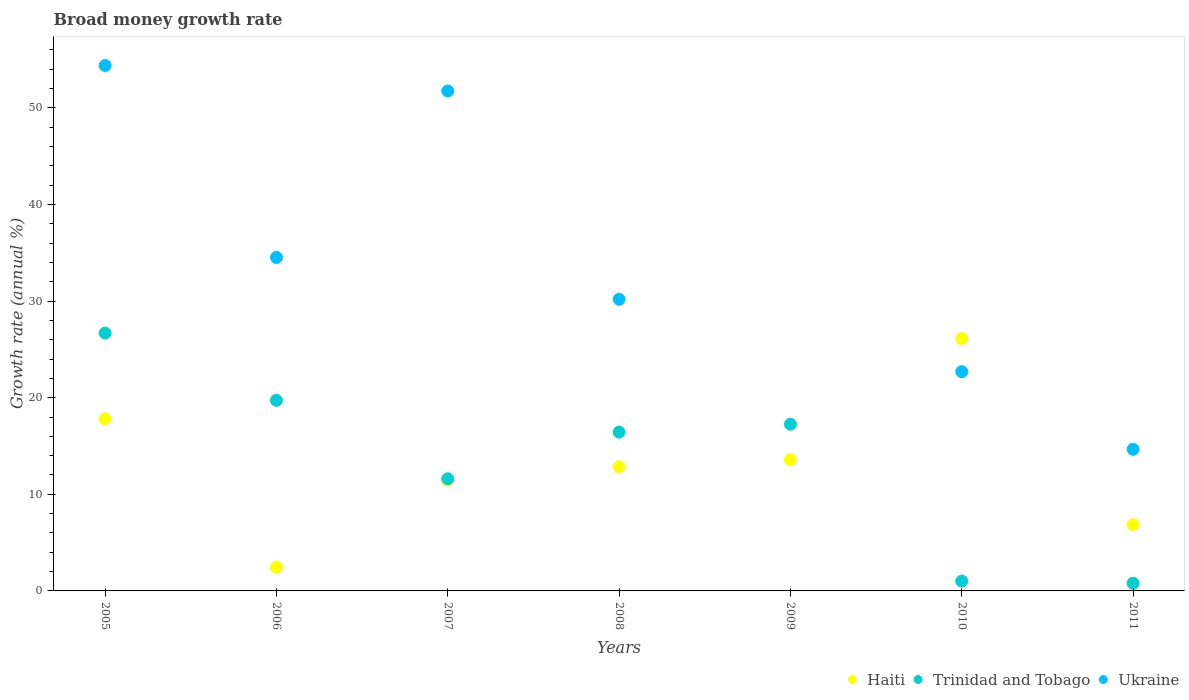How many different coloured dotlines are there?
Make the answer very short. 3. What is the growth rate in Ukraine in 2011?
Keep it short and to the point. 14.66. Across all years, what is the maximum growth rate in Trinidad and Tobago?
Give a very brief answer. 26.69. What is the total growth rate in Haiti in the graph?
Ensure brevity in your answer.  91.12. What is the difference between the growth rate in Haiti in 2009 and that in 2010?
Provide a short and direct response. -12.52. What is the difference between the growth rate in Trinidad and Tobago in 2008 and the growth rate in Haiti in 2009?
Provide a short and direct response. 2.85. What is the average growth rate in Trinidad and Tobago per year?
Your response must be concise. 13.36. In the year 2006, what is the difference between the growth rate in Trinidad and Tobago and growth rate in Haiti?
Make the answer very short. 17.29. What is the ratio of the growth rate in Ukraine in 2005 to that in 2007?
Ensure brevity in your answer.  1.05. Is the growth rate in Trinidad and Tobago in 2009 less than that in 2010?
Your answer should be very brief. No. Is the difference between the growth rate in Trinidad and Tobago in 2010 and 2011 greater than the difference between the growth rate in Haiti in 2010 and 2011?
Give a very brief answer. No. What is the difference between the highest and the second highest growth rate in Trinidad and Tobago?
Give a very brief answer. 6.96. What is the difference between the highest and the lowest growth rate in Trinidad and Tobago?
Provide a short and direct response. 25.9. In how many years, is the growth rate in Ukraine greater than the average growth rate in Ukraine taken over all years?
Provide a succinct answer. 4. Does the growth rate in Ukraine monotonically increase over the years?
Ensure brevity in your answer.  No. Is the growth rate in Ukraine strictly greater than the growth rate in Trinidad and Tobago over the years?
Ensure brevity in your answer.  No. What is the difference between two consecutive major ticks on the Y-axis?
Ensure brevity in your answer.  10. Are the values on the major ticks of Y-axis written in scientific E-notation?
Keep it short and to the point. No. Does the graph contain grids?
Make the answer very short. No. How many legend labels are there?
Ensure brevity in your answer.  3. How are the legend labels stacked?
Offer a very short reply. Horizontal. What is the title of the graph?
Ensure brevity in your answer.  Broad money growth rate. What is the label or title of the X-axis?
Keep it short and to the point. Years. What is the label or title of the Y-axis?
Your answer should be compact. Growth rate (annual %). What is the Growth rate (annual %) in Haiti in 2005?
Keep it short and to the point. 17.82. What is the Growth rate (annual %) of Trinidad and Tobago in 2005?
Offer a terse response. 26.69. What is the Growth rate (annual %) of Ukraine in 2005?
Offer a very short reply. 54.39. What is the Growth rate (annual %) of Haiti in 2006?
Your answer should be compact. 2.44. What is the Growth rate (annual %) of Trinidad and Tobago in 2006?
Your answer should be compact. 19.73. What is the Growth rate (annual %) of Ukraine in 2006?
Your answer should be compact. 34.52. What is the Growth rate (annual %) in Haiti in 2007?
Your answer should be very brief. 11.47. What is the Growth rate (annual %) of Trinidad and Tobago in 2007?
Make the answer very short. 11.61. What is the Growth rate (annual %) in Ukraine in 2007?
Ensure brevity in your answer.  51.75. What is the Growth rate (annual %) in Haiti in 2008?
Offer a terse response. 12.85. What is the Growth rate (annual %) in Trinidad and Tobago in 2008?
Offer a very short reply. 16.44. What is the Growth rate (annual %) of Ukraine in 2008?
Offer a terse response. 30.18. What is the Growth rate (annual %) in Haiti in 2009?
Your answer should be very brief. 13.59. What is the Growth rate (annual %) in Trinidad and Tobago in 2009?
Your answer should be very brief. 17.25. What is the Growth rate (annual %) in Haiti in 2010?
Offer a very short reply. 26.12. What is the Growth rate (annual %) of Trinidad and Tobago in 2010?
Keep it short and to the point. 1.02. What is the Growth rate (annual %) in Ukraine in 2010?
Provide a short and direct response. 22.69. What is the Growth rate (annual %) in Haiti in 2011?
Provide a short and direct response. 6.84. What is the Growth rate (annual %) of Trinidad and Tobago in 2011?
Your answer should be very brief. 0.79. What is the Growth rate (annual %) in Ukraine in 2011?
Your response must be concise. 14.66. Across all years, what is the maximum Growth rate (annual %) in Haiti?
Your answer should be compact. 26.12. Across all years, what is the maximum Growth rate (annual %) in Trinidad and Tobago?
Make the answer very short. 26.69. Across all years, what is the maximum Growth rate (annual %) in Ukraine?
Offer a terse response. 54.39. Across all years, what is the minimum Growth rate (annual %) of Haiti?
Your answer should be very brief. 2.44. Across all years, what is the minimum Growth rate (annual %) of Trinidad and Tobago?
Provide a succinct answer. 0.79. Across all years, what is the minimum Growth rate (annual %) in Ukraine?
Ensure brevity in your answer.  0. What is the total Growth rate (annual %) in Haiti in the graph?
Offer a terse response. 91.12. What is the total Growth rate (annual %) of Trinidad and Tobago in the graph?
Make the answer very short. 93.53. What is the total Growth rate (annual %) of Ukraine in the graph?
Offer a very short reply. 208.19. What is the difference between the Growth rate (annual %) in Haiti in 2005 and that in 2006?
Provide a succinct answer. 15.38. What is the difference between the Growth rate (annual %) of Trinidad and Tobago in 2005 and that in 2006?
Provide a succinct answer. 6.96. What is the difference between the Growth rate (annual %) of Ukraine in 2005 and that in 2006?
Make the answer very short. 19.87. What is the difference between the Growth rate (annual %) in Haiti in 2005 and that in 2007?
Your response must be concise. 6.35. What is the difference between the Growth rate (annual %) of Trinidad and Tobago in 2005 and that in 2007?
Your answer should be compact. 15.08. What is the difference between the Growth rate (annual %) of Ukraine in 2005 and that in 2007?
Ensure brevity in your answer.  2.64. What is the difference between the Growth rate (annual %) of Haiti in 2005 and that in 2008?
Offer a very short reply. 4.97. What is the difference between the Growth rate (annual %) in Trinidad and Tobago in 2005 and that in 2008?
Your answer should be compact. 10.25. What is the difference between the Growth rate (annual %) of Ukraine in 2005 and that in 2008?
Make the answer very short. 24.2. What is the difference between the Growth rate (annual %) in Haiti in 2005 and that in 2009?
Provide a succinct answer. 4.23. What is the difference between the Growth rate (annual %) in Trinidad and Tobago in 2005 and that in 2009?
Give a very brief answer. 9.44. What is the difference between the Growth rate (annual %) in Haiti in 2005 and that in 2010?
Provide a succinct answer. -8.3. What is the difference between the Growth rate (annual %) in Trinidad and Tobago in 2005 and that in 2010?
Your answer should be compact. 25.67. What is the difference between the Growth rate (annual %) in Ukraine in 2005 and that in 2010?
Your answer should be compact. 31.69. What is the difference between the Growth rate (annual %) of Haiti in 2005 and that in 2011?
Keep it short and to the point. 10.98. What is the difference between the Growth rate (annual %) in Trinidad and Tobago in 2005 and that in 2011?
Keep it short and to the point. 25.9. What is the difference between the Growth rate (annual %) in Ukraine in 2005 and that in 2011?
Make the answer very short. 39.73. What is the difference between the Growth rate (annual %) of Haiti in 2006 and that in 2007?
Provide a succinct answer. -9.02. What is the difference between the Growth rate (annual %) of Trinidad and Tobago in 2006 and that in 2007?
Your answer should be very brief. 8.13. What is the difference between the Growth rate (annual %) in Ukraine in 2006 and that in 2007?
Provide a short and direct response. -17.23. What is the difference between the Growth rate (annual %) of Haiti in 2006 and that in 2008?
Make the answer very short. -10.4. What is the difference between the Growth rate (annual %) of Trinidad and Tobago in 2006 and that in 2008?
Ensure brevity in your answer.  3.3. What is the difference between the Growth rate (annual %) of Ukraine in 2006 and that in 2008?
Make the answer very short. 4.34. What is the difference between the Growth rate (annual %) of Haiti in 2006 and that in 2009?
Offer a terse response. -11.15. What is the difference between the Growth rate (annual %) in Trinidad and Tobago in 2006 and that in 2009?
Offer a terse response. 2.48. What is the difference between the Growth rate (annual %) of Haiti in 2006 and that in 2010?
Keep it short and to the point. -23.67. What is the difference between the Growth rate (annual %) of Trinidad and Tobago in 2006 and that in 2010?
Ensure brevity in your answer.  18.72. What is the difference between the Growth rate (annual %) in Ukraine in 2006 and that in 2010?
Your answer should be compact. 11.83. What is the difference between the Growth rate (annual %) of Haiti in 2006 and that in 2011?
Give a very brief answer. -4.4. What is the difference between the Growth rate (annual %) in Trinidad and Tobago in 2006 and that in 2011?
Provide a short and direct response. 18.94. What is the difference between the Growth rate (annual %) in Ukraine in 2006 and that in 2011?
Make the answer very short. 19.86. What is the difference between the Growth rate (annual %) in Haiti in 2007 and that in 2008?
Provide a short and direct response. -1.38. What is the difference between the Growth rate (annual %) in Trinidad and Tobago in 2007 and that in 2008?
Keep it short and to the point. -4.83. What is the difference between the Growth rate (annual %) in Ukraine in 2007 and that in 2008?
Provide a short and direct response. 21.56. What is the difference between the Growth rate (annual %) in Haiti in 2007 and that in 2009?
Ensure brevity in your answer.  -2.12. What is the difference between the Growth rate (annual %) in Trinidad and Tobago in 2007 and that in 2009?
Provide a short and direct response. -5.65. What is the difference between the Growth rate (annual %) in Haiti in 2007 and that in 2010?
Provide a short and direct response. -14.65. What is the difference between the Growth rate (annual %) in Trinidad and Tobago in 2007 and that in 2010?
Give a very brief answer. 10.59. What is the difference between the Growth rate (annual %) in Ukraine in 2007 and that in 2010?
Offer a terse response. 29.06. What is the difference between the Growth rate (annual %) in Haiti in 2007 and that in 2011?
Your response must be concise. 4.62. What is the difference between the Growth rate (annual %) of Trinidad and Tobago in 2007 and that in 2011?
Provide a short and direct response. 10.82. What is the difference between the Growth rate (annual %) of Ukraine in 2007 and that in 2011?
Offer a very short reply. 37.09. What is the difference between the Growth rate (annual %) in Haiti in 2008 and that in 2009?
Your response must be concise. -0.75. What is the difference between the Growth rate (annual %) in Trinidad and Tobago in 2008 and that in 2009?
Your answer should be compact. -0.82. What is the difference between the Growth rate (annual %) of Haiti in 2008 and that in 2010?
Keep it short and to the point. -13.27. What is the difference between the Growth rate (annual %) in Trinidad and Tobago in 2008 and that in 2010?
Provide a short and direct response. 15.42. What is the difference between the Growth rate (annual %) of Ukraine in 2008 and that in 2010?
Offer a terse response. 7.49. What is the difference between the Growth rate (annual %) in Haiti in 2008 and that in 2011?
Provide a succinct answer. 6. What is the difference between the Growth rate (annual %) in Trinidad and Tobago in 2008 and that in 2011?
Give a very brief answer. 15.65. What is the difference between the Growth rate (annual %) of Ukraine in 2008 and that in 2011?
Ensure brevity in your answer.  15.52. What is the difference between the Growth rate (annual %) of Haiti in 2009 and that in 2010?
Make the answer very short. -12.52. What is the difference between the Growth rate (annual %) of Trinidad and Tobago in 2009 and that in 2010?
Provide a short and direct response. 16.24. What is the difference between the Growth rate (annual %) in Haiti in 2009 and that in 2011?
Your response must be concise. 6.75. What is the difference between the Growth rate (annual %) of Trinidad and Tobago in 2009 and that in 2011?
Keep it short and to the point. 16.46. What is the difference between the Growth rate (annual %) of Haiti in 2010 and that in 2011?
Offer a terse response. 19.27. What is the difference between the Growth rate (annual %) of Trinidad and Tobago in 2010 and that in 2011?
Provide a short and direct response. 0.23. What is the difference between the Growth rate (annual %) of Ukraine in 2010 and that in 2011?
Your answer should be very brief. 8.03. What is the difference between the Growth rate (annual %) of Haiti in 2005 and the Growth rate (annual %) of Trinidad and Tobago in 2006?
Provide a succinct answer. -1.92. What is the difference between the Growth rate (annual %) of Haiti in 2005 and the Growth rate (annual %) of Ukraine in 2006?
Offer a very short reply. -16.7. What is the difference between the Growth rate (annual %) in Trinidad and Tobago in 2005 and the Growth rate (annual %) in Ukraine in 2006?
Keep it short and to the point. -7.83. What is the difference between the Growth rate (annual %) of Haiti in 2005 and the Growth rate (annual %) of Trinidad and Tobago in 2007?
Make the answer very short. 6.21. What is the difference between the Growth rate (annual %) of Haiti in 2005 and the Growth rate (annual %) of Ukraine in 2007?
Give a very brief answer. -33.93. What is the difference between the Growth rate (annual %) in Trinidad and Tobago in 2005 and the Growth rate (annual %) in Ukraine in 2007?
Provide a succinct answer. -25.06. What is the difference between the Growth rate (annual %) of Haiti in 2005 and the Growth rate (annual %) of Trinidad and Tobago in 2008?
Your answer should be compact. 1.38. What is the difference between the Growth rate (annual %) of Haiti in 2005 and the Growth rate (annual %) of Ukraine in 2008?
Provide a short and direct response. -12.36. What is the difference between the Growth rate (annual %) of Trinidad and Tobago in 2005 and the Growth rate (annual %) of Ukraine in 2008?
Provide a short and direct response. -3.49. What is the difference between the Growth rate (annual %) of Haiti in 2005 and the Growth rate (annual %) of Trinidad and Tobago in 2009?
Ensure brevity in your answer.  0.57. What is the difference between the Growth rate (annual %) in Haiti in 2005 and the Growth rate (annual %) in Trinidad and Tobago in 2010?
Provide a short and direct response. 16.8. What is the difference between the Growth rate (annual %) in Haiti in 2005 and the Growth rate (annual %) in Ukraine in 2010?
Keep it short and to the point. -4.87. What is the difference between the Growth rate (annual %) in Trinidad and Tobago in 2005 and the Growth rate (annual %) in Ukraine in 2010?
Keep it short and to the point. 4. What is the difference between the Growth rate (annual %) in Haiti in 2005 and the Growth rate (annual %) in Trinidad and Tobago in 2011?
Provide a short and direct response. 17.03. What is the difference between the Growth rate (annual %) of Haiti in 2005 and the Growth rate (annual %) of Ukraine in 2011?
Ensure brevity in your answer.  3.16. What is the difference between the Growth rate (annual %) in Trinidad and Tobago in 2005 and the Growth rate (annual %) in Ukraine in 2011?
Your answer should be compact. 12.03. What is the difference between the Growth rate (annual %) in Haiti in 2006 and the Growth rate (annual %) in Trinidad and Tobago in 2007?
Your response must be concise. -9.16. What is the difference between the Growth rate (annual %) of Haiti in 2006 and the Growth rate (annual %) of Ukraine in 2007?
Give a very brief answer. -49.3. What is the difference between the Growth rate (annual %) in Trinidad and Tobago in 2006 and the Growth rate (annual %) in Ukraine in 2007?
Your answer should be compact. -32.01. What is the difference between the Growth rate (annual %) of Haiti in 2006 and the Growth rate (annual %) of Trinidad and Tobago in 2008?
Offer a very short reply. -13.99. What is the difference between the Growth rate (annual %) of Haiti in 2006 and the Growth rate (annual %) of Ukraine in 2008?
Provide a short and direct response. -27.74. What is the difference between the Growth rate (annual %) in Trinidad and Tobago in 2006 and the Growth rate (annual %) in Ukraine in 2008?
Provide a short and direct response. -10.45. What is the difference between the Growth rate (annual %) of Haiti in 2006 and the Growth rate (annual %) of Trinidad and Tobago in 2009?
Offer a terse response. -14.81. What is the difference between the Growth rate (annual %) of Haiti in 2006 and the Growth rate (annual %) of Trinidad and Tobago in 2010?
Ensure brevity in your answer.  1.43. What is the difference between the Growth rate (annual %) of Haiti in 2006 and the Growth rate (annual %) of Ukraine in 2010?
Offer a terse response. -20.25. What is the difference between the Growth rate (annual %) in Trinidad and Tobago in 2006 and the Growth rate (annual %) in Ukraine in 2010?
Ensure brevity in your answer.  -2.96. What is the difference between the Growth rate (annual %) in Haiti in 2006 and the Growth rate (annual %) in Trinidad and Tobago in 2011?
Provide a short and direct response. 1.65. What is the difference between the Growth rate (annual %) in Haiti in 2006 and the Growth rate (annual %) in Ukraine in 2011?
Provide a short and direct response. -12.22. What is the difference between the Growth rate (annual %) of Trinidad and Tobago in 2006 and the Growth rate (annual %) of Ukraine in 2011?
Make the answer very short. 5.08. What is the difference between the Growth rate (annual %) in Haiti in 2007 and the Growth rate (annual %) in Trinidad and Tobago in 2008?
Offer a very short reply. -4.97. What is the difference between the Growth rate (annual %) of Haiti in 2007 and the Growth rate (annual %) of Ukraine in 2008?
Provide a succinct answer. -18.72. What is the difference between the Growth rate (annual %) in Trinidad and Tobago in 2007 and the Growth rate (annual %) in Ukraine in 2008?
Your answer should be compact. -18.58. What is the difference between the Growth rate (annual %) of Haiti in 2007 and the Growth rate (annual %) of Trinidad and Tobago in 2009?
Your answer should be very brief. -5.79. What is the difference between the Growth rate (annual %) of Haiti in 2007 and the Growth rate (annual %) of Trinidad and Tobago in 2010?
Ensure brevity in your answer.  10.45. What is the difference between the Growth rate (annual %) of Haiti in 2007 and the Growth rate (annual %) of Ukraine in 2010?
Your response must be concise. -11.22. What is the difference between the Growth rate (annual %) in Trinidad and Tobago in 2007 and the Growth rate (annual %) in Ukraine in 2010?
Ensure brevity in your answer.  -11.08. What is the difference between the Growth rate (annual %) of Haiti in 2007 and the Growth rate (annual %) of Trinidad and Tobago in 2011?
Give a very brief answer. 10.68. What is the difference between the Growth rate (annual %) in Haiti in 2007 and the Growth rate (annual %) in Ukraine in 2011?
Make the answer very short. -3.19. What is the difference between the Growth rate (annual %) in Trinidad and Tobago in 2007 and the Growth rate (annual %) in Ukraine in 2011?
Offer a very short reply. -3.05. What is the difference between the Growth rate (annual %) in Haiti in 2008 and the Growth rate (annual %) in Trinidad and Tobago in 2009?
Provide a succinct answer. -4.41. What is the difference between the Growth rate (annual %) in Haiti in 2008 and the Growth rate (annual %) in Trinidad and Tobago in 2010?
Give a very brief answer. 11.83. What is the difference between the Growth rate (annual %) in Haiti in 2008 and the Growth rate (annual %) in Ukraine in 2010?
Your answer should be compact. -9.85. What is the difference between the Growth rate (annual %) of Trinidad and Tobago in 2008 and the Growth rate (annual %) of Ukraine in 2010?
Offer a very short reply. -6.25. What is the difference between the Growth rate (annual %) of Haiti in 2008 and the Growth rate (annual %) of Trinidad and Tobago in 2011?
Keep it short and to the point. 12.06. What is the difference between the Growth rate (annual %) of Haiti in 2008 and the Growth rate (annual %) of Ukraine in 2011?
Your answer should be compact. -1.81. What is the difference between the Growth rate (annual %) of Trinidad and Tobago in 2008 and the Growth rate (annual %) of Ukraine in 2011?
Ensure brevity in your answer.  1.78. What is the difference between the Growth rate (annual %) of Haiti in 2009 and the Growth rate (annual %) of Trinidad and Tobago in 2010?
Your answer should be very brief. 12.57. What is the difference between the Growth rate (annual %) of Haiti in 2009 and the Growth rate (annual %) of Ukraine in 2010?
Provide a short and direct response. -9.1. What is the difference between the Growth rate (annual %) in Trinidad and Tobago in 2009 and the Growth rate (annual %) in Ukraine in 2010?
Offer a terse response. -5.44. What is the difference between the Growth rate (annual %) in Haiti in 2009 and the Growth rate (annual %) in Trinidad and Tobago in 2011?
Provide a succinct answer. 12.8. What is the difference between the Growth rate (annual %) of Haiti in 2009 and the Growth rate (annual %) of Ukraine in 2011?
Your response must be concise. -1.07. What is the difference between the Growth rate (annual %) in Trinidad and Tobago in 2009 and the Growth rate (annual %) in Ukraine in 2011?
Provide a short and direct response. 2.59. What is the difference between the Growth rate (annual %) of Haiti in 2010 and the Growth rate (annual %) of Trinidad and Tobago in 2011?
Your answer should be compact. 25.33. What is the difference between the Growth rate (annual %) in Haiti in 2010 and the Growth rate (annual %) in Ukraine in 2011?
Your response must be concise. 11.46. What is the difference between the Growth rate (annual %) in Trinidad and Tobago in 2010 and the Growth rate (annual %) in Ukraine in 2011?
Keep it short and to the point. -13.64. What is the average Growth rate (annual %) in Haiti per year?
Give a very brief answer. 13.02. What is the average Growth rate (annual %) in Trinidad and Tobago per year?
Your answer should be compact. 13.36. What is the average Growth rate (annual %) of Ukraine per year?
Your response must be concise. 29.74. In the year 2005, what is the difference between the Growth rate (annual %) in Haiti and Growth rate (annual %) in Trinidad and Tobago?
Make the answer very short. -8.87. In the year 2005, what is the difference between the Growth rate (annual %) in Haiti and Growth rate (annual %) in Ukraine?
Keep it short and to the point. -36.57. In the year 2005, what is the difference between the Growth rate (annual %) in Trinidad and Tobago and Growth rate (annual %) in Ukraine?
Ensure brevity in your answer.  -27.69. In the year 2006, what is the difference between the Growth rate (annual %) in Haiti and Growth rate (annual %) in Trinidad and Tobago?
Make the answer very short. -17.29. In the year 2006, what is the difference between the Growth rate (annual %) of Haiti and Growth rate (annual %) of Ukraine?
Provide a succinct answer. -32.08. In the year 2006, what is the difference between the Growth rate (annual %) of Trinidad and Tobago and Growth rate (annual %) of Ukraine?
Provide a succinct answer. -14.79. In the year 2007, what is the difference between the Growth rate (annual %) of Haiti and Growth rate (annual %) of Trinidad and Tobago?
Offer a very short reply. -0.14. In the year 2007, what is the difference between the Growth rate (annual %) in Haiti and Growth rate (annual %) in Ukraine?
Provide a short and direct response. -40.28. In the year 2007, what is the difference between the Growth rate (annual %) in Trinidad and Tobago and Growth rate (annual %) in Ukraine?
Give a very brief answer. -40.14. In the year 2008, what is the difference between the Growth rate (annual %) of Haiti and Growth rate (annual %) of Trinidad and Tobago?
Make the answer very short. -3.59. In the year 2008, what is the difference between the Growth rate (annual %) of Haiti and Growth rate (annual %) of Ukraine?
Offer a very short reply. -17.34. In the year 2008, what is the difference between the Growth rate (annual %) in Trinidad and Tobago and Growth rate (annual %) in Ukraine?
Your answer should be compact. -13.74. In the year 2009, what is the difference between the Growth rate (annual %) in Haiti and Growth rate (annual %) in Trinidad and Tobago?
Your answer should be very brief. -3.66. In the year 2010, what is the difference between the Growth rate (annual %) of Haiti and Growth rate (annual %) of Trinidad and Tobago?
Give a very brief answer. 25.1. In the year 2010, what is the difference between the Growth rate (annual %) of Haiti and Growth rate (annual %) of Ukraine?
Provide a short and direct response. 3.42. In the year 2010, what is the difference between the Growth rate (annual %) in Trinidad and Tobago and Growth rate (annual %) in Ukraine?
Provide a succinct answer. -21.67. In the year 2011, what is the difference between the Growth rate (annual %) in Haiti and Growth rate (annual %) in Trinidad and Tobago?
Provide a short and direct response. 6.05. In the year 2011, what is the difference between the Growth rate (annual %) in Haiti and Growth rate (annual %) in Ukraine?
Provide a succinct answer. -7.82. In the year 2011, what is the difference between the Growth rate (annual %) of Trinidad and Tobago and Growth rate (annual %) of Ukraine?
Your answer should be compact. -13.87. What is the ratio of the Growth rate (annual %) of Haiti in 2005 to that in 2006?
Ensure brevity in your answer.  7.29. What is the ratio of the Growth rate (annual %) of Trinidad and Tobago in 2005 to that in 2006?
Offer a terse response. 1.35. What is the ratio of the Growth rate (annual %) in Ukraine in 2005 to that in 2006?
Offer a very short reply. 1.58. What is the ratio of the Growth rate (annual %) of Haiti in 2005 to that in 2007?
Provide a succinct answer. 1.55. What is the ratio of the Growth rate (annual %) of Trinidad and Tobago in 2005 to that in 2007?
Your answer should be compact. 2.3. What is the ratio of the Growth rate (annual %) of Ukraine in 2005 to that in 2007?
Give a very brief answer. 1.05. What is the ratio of the Growth rate (annual %) of Haiti in 2005 to that in 2008?
Keep it short and to the point. 1.39. What is the ratio of the Growth rate (annual %) of Trinidad and Tobago in 2005 to that in 2008?
Keep it short and to the point. 1.62. What is the ratio of the Growth rate (annual %) in Ukraine in 2005 to that in 2008?
Your answer should be compact. 1.8. What is the ratio of the Growth rate (annual %) in Haiti in 2005 to that in 2009?
Your answer should be very brief. 1.31. What is the ratio of the Growth rate (annual %) in Trinidad and Tobago in 2005 to that in 2009?
Your answer should be very brief. 1.55. What is the ratio of the Growth rate (annual %) of Haiti in 2005 to that in 2010?
Offer a very short reply. 0.68. What is the ratio of the Growth rate (annual %) of Trinidad and Tobago in 2005 to that in 2010?
Your answer should be very brief. 26.24. What is the ratio of the Growth rate (annual %) in Ukraine in 2005 to that in 2010?
Your response must be concise. 2.4. What is the ratio of the Growth rate (annual %) of Haiti in 2005 to that in 2011?
Provide a succinct answer. 2.6. What is the ratio of the Growth rate (annual %) in Trinidad and Tobago in 2005 to that in 2011?
Your answer should be compact. 33.81. What is the ratio of the Growth rate (annual %) in Ukraine in 2005 to that in 2011?
Offer a terse response. 3.71. What is the ratio of the Growth rate (annual %) in Haiti in 2006 to that in 2007?
Your response must be concise. 0.21. What is the ratio of the Growth rate (annual %) of Trinidad and Tobago in 2006 to that in 2007?
Offer a terse response. 1.7. What is the ratio of the Growth rate (annual %) of Ukraine in 2006 to that in 2007?
Give a very brief answer. 0.67. What is the ratio of the Growth rate (annual %) of Haiti in 2006 to that in 2008?
Offer a terse response. 0.19. What is the ratio of the Growth rate (annual %) in Trinidad and Tobago in 2006 to that in 2008?
Ensure brevity in your answer.  1.2. What is the ratio of the Growth rate (annual %) in Ukraine in 2006 to that in 2008?
Provide a succinct answer. 1.14. What is the ratio of the Growth rate (annual %) in Haiti in 2006 to that in 2009?
Make the answer very short. 0.18. What is the ratio of the Growth rate (annual %) in Trinidad and Tobago in 2006 to that in 2009?
Offer a very short reply. 1.14. What is the ratio of the Growth rate (annual %) in Haiti in 2006 to that in 2010?
Ensure brevity in your answer.  0.09. What is the ratio of the Growth rate (annual %) in Trinidad and Tobago in 2006 to that in 2010?
Your answer should be very brief. 19.4. What is the ratio of the Growth rate (annual %) in Ukraine in 2006 to that in 2010?
Your response must be concise. 1.52. What is the ratio of the Growth rate (annual %) of Haiti in 2006 to that in 2011?
Give a very brief answer. 0.36. What is the ratio of the Growth rate (annual %) of Trinidad and Tobago in 2006 to that in 2011?
Keep it short and to the point. 25. What is the ratio of the Growth rate (annual %) of Ukraine in 2006 to that in 2011?
Provide a short and direct response. 2.35. What is the ratio of the Growth rate (annual %) in Haiti in 2007 to that in 2008?
Your answer should be compact. 0.89. What is the ratio of the Growth rate (annual %) in Trinidad and Tobago in 2007 to that in 2008?
Your answer should be very brief. 0.71. What is the ratio of the Growth rate (annual %) in Ukraine in 2007 to that in 2008?
Your response must be concise. 1.71. What is the ratio of the Growth rate (annual %) of Haiti in 2007 to that in 2009?
Provide a succinct answer. 0.84. What is the ratio of the Growth rate (annual %) of Trinidad and Tobago in 2007 to that in 2009?
Provide a succinct answer. 0.67. What is the ratio of the Growth rate (annual %) in Haiti in 2007 to that in 2010?
Your answer should be very brief. 0.44. What is the ratio of the Growth rate (annual %) in Trinidad and Tobago in 2007 to that in 2010?
Provide a succinct answer. 11.41. What is the ratio of the Growth rate (annual %) of Ukraine in 2007 to that in 2010?
Make the answer very short. 2.28. What is the ratio of the Growth rate (annual %) of Haiti in 2007 to that in 2011?
Make the answer very short. 1.68. What is the ratio of the Growth rate (annual %) in Trinidad and Tobago in 2007 to that in 2011?
Ensure brevity in your answer.  14.7. What is the ratio of the Growth rate (annual %) in Ukraine in 2007 to that in 2011?
Your answer should be very brief. 3.53. What is the ratio of the Growth rate (annual %) in Haiti in 2008 to that in 2009?
Your answer should be very brief. 0.94. What is the ratio of the Growth rate (annual %) in Trinidad and Tobago in 2008 to that in 2009?
Your response must be concise. 0.95. What is the ratio of the Growth rate (annual %) of Haiti in 2008 to that in 2010?
Your response must be concise. 0.49. What is the ratio of the Growth rate (annual %) of Trinidad and Tobago in 2008 to that in 2010?
Give a very brief answer. 16.16. What is the ratio of the Growth rate (annual %) of Ukraine in 2008 to that in 2010?
Your answer should be very brief. 1.33. What is the ratio of the Growth rate (annual %) of Haiti in 2008 to that in 2011?
Ensure brevity in your answer.  1.88. What is the ratio of the Growth rate (annual %) of Trinidad and Tobago in 2008 to that in 2011?
Offer a very short reply. 20.82. What is the ratio of the Growth rate (annual %) in Ukraine in 2008 to that in 2011?
Offer a very short reply. 2.06. What is the ratio of the Growth rate (annual %) of Haiti in 2009 to that in 2010?
Provide a succinct answer. 0.52. What is the ratio of the Growth rate (annual %) in Trinidad and Tobago in 2009 to that in 2010?
Offer a very short reply. 16.96. What is the ratio of the Growth rate (annual %) of Haiti in 2009 to that in 2011?
Provide a short and direct response. 1.99. What is the ratio of the Growth rate (annual %) in Trinidad and Tobago in 2009 to that in 2011?
Give a very brief answer. 21.86. What is the ratio of the Growth rate (annual %) in Haiti in 2010 to that in 2011?
Your answer should be very brief. 3.82. What is the ratio of the Growth rate (annual %) of Trinidad and Tobago in 2010 to that in 2011?
Ensure brevity in your answer.  1.29. What is the ratio of the Growth rate (annual %) of Ukraine in 2010 to that in 2011?
Your answer should be compact. 1.55. What is the difference between the highest and the second highest Growth rate (annual %) of Haiti?
Offer a terse response. 8.3. What is the difference between the highest and the second highest Growth rate (annual %) of Trinidad and Tobago?
Offer a terse response. 6.96. What is the difference between the highest and the second highest Growth rate (annual %) in Ukraine?
Offer a very short reply. 2.64. What is the difference between the highest and the lowest Growth rate (annual %) in Haiti?
Provide a succinct answer. 23.67. What is the difference between the highest and the lowest Growth rate (annual %) of Trinidad and Tobago?
Keep it short and to the point. 25.9. What is the difference between the highest and the lowest Growth rate (annual %) of Ukraine?
Offer a very short reply. 54.39. 